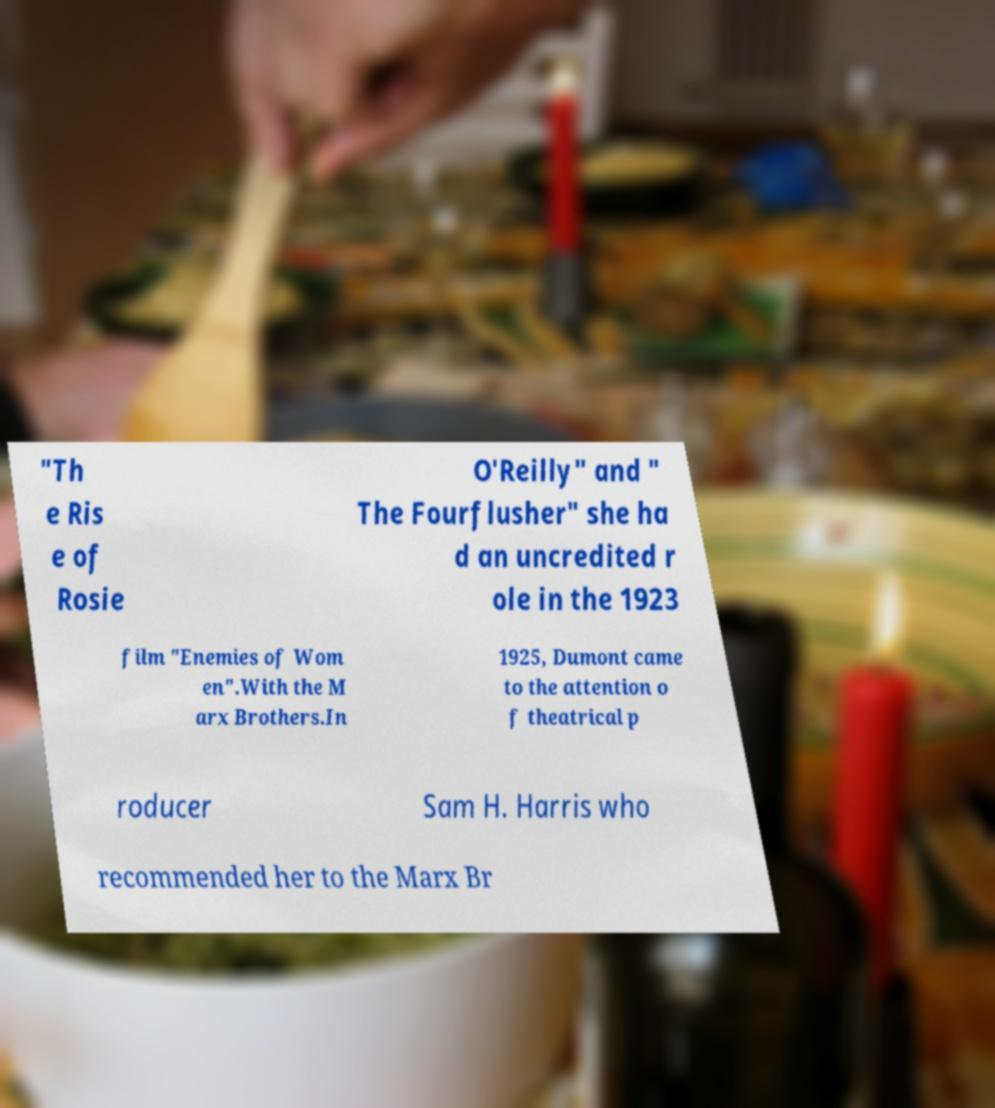Can you read and provide the text displayed in the image?This photo seems to have some interesting text. Can you extract and type it out for me? "Th e Ris e of Rosie O'Reilly" and " The Fourflusher" she ha d an uncredited r ole in the 1923 film "Enemies of Wom en".With the M arx Brothers.In 1925, Dumont came to the attention o f theatrical p roducer Sam H. Harris who recommended her to the Marx Br 